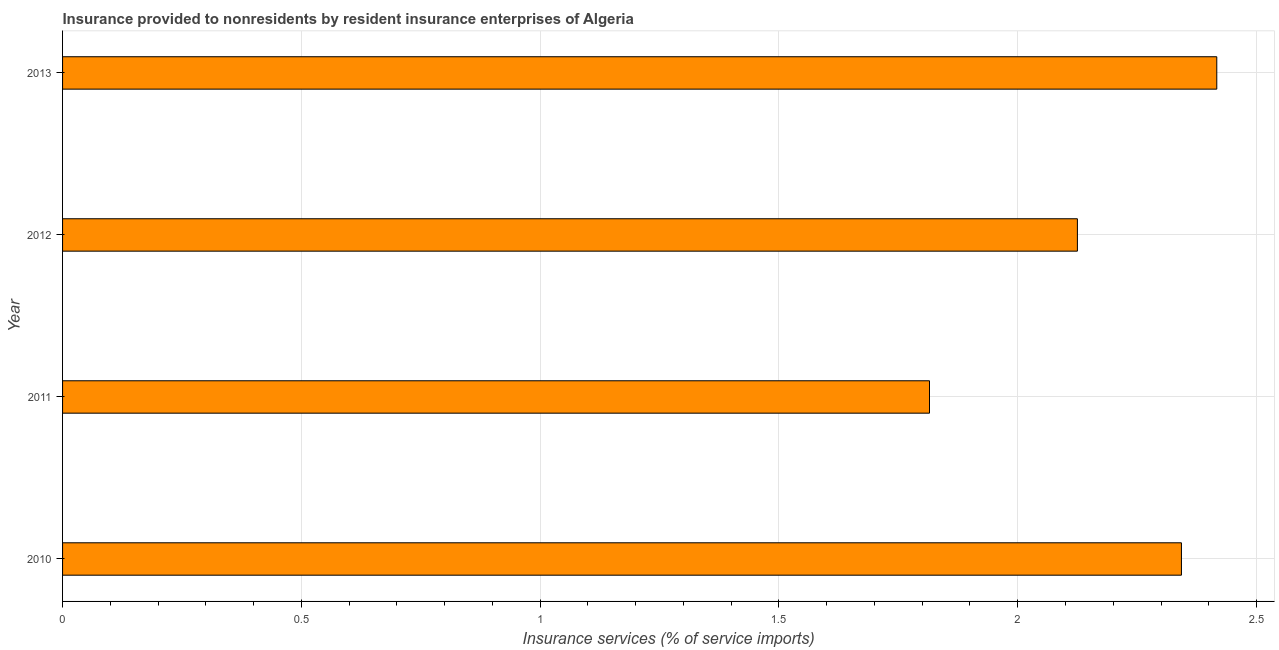Does the graph contain any zero values?
Your answer should be very brief. No. Does the graph contain grids?
Your answer should be compact. Yes. What is the title of the graph?
Your answer should be very brief. Insurance provided to nonresidents by resident insurance enterprises of Algeria. What is the label or title of the X-axis?
Your answer should be very brief. Insurance services (% of service imports). What is the label or title of the Y-axis?
Keep it short and to the point. Year. What is the insurance and financial services in 2011?
Provide a succinct answer. 1.82. Across all years, what is the maximum insurance and financial services?
Provide a short and direct response. 2.42. Across all years, what is the minimum insurance and financial services?
Keep it short and to the point. 1.82. In which year was the insurance and financial services minimum?
Offer a terse response. 2011. What is the sum of the insurance and financial services?
Your answer should be very brief. 8.7. What is the difference between the insurance and financial services in 2010 and 2011?
Make the answer very short. 0.53. What is the average insurance and financial services per year?
Offer a very short reply. 2.17. What is the median insurance and financial services?
Ensure brevity in your answer.  2.23. Do a majority of the years between 2013 and 2012 (inclusive) have insurance and financial services greater than 2 %?
Ensure brevity in your answer.  No. What is the ratio of the insurance and financial services in 2010 to that in 2012?
Ensure brevity in your answer.  1.1. Is the insurance and financial services in 2010 less than that in 2012?
Offer a terse response. No. What is the difference between the highest and the second highest insurance and financial services?
Ensure brevity in your answer.  0.07. In how many years, is the insurance and financial services greater than the average insurance and financial services taken over all years?
Offer a very short reply. 2. Are all the bars in the graph horizontal?
Your answer should be compact. Yes. How many years are there in the graph?
Provide a short and direct response. 4. What is the difference between two consecutive major ticks on the X-axis?
Your answer should be compact. 0.5. Are the values on the major ticks of X-axis written in scientific E-notation?
Your response must be concise. No. What is the Insurance services (% of service imports) of 2010?
Make the answer very short. 2.34. What is the Insurance services (% of service imports) of 2011?
Give a very brief answer. 1.82. What is the Insurance services (% of service imports) of 2012?
Provide a succinct answer. 2.12. What is the Insurance services (% of service imports) in 2013?
Provide a short and direct response. 2.42. What is the difference between the Insurance services (% of service imports) in 2010 and 2011?
Offer a very short reply. 0.53. What is the difference between the Insurance services (% of service imports) in 2010 and 2012?
Give a very brief answer. 0.22. What is the difference between the Insurance services (% of service imports) in 2010 and 2013?
Make the answer very short. -0.07. What is the difference between the Insurance services (% of service imports) in 2011 and 2012?
Ensure brevity in your answer.  -0.31. What is the difference between the Insurance services (% of service imports) in 2011 and 2013?
Your answer should be compact. -0.6. What is the difference between the Insurance services (% of service imports) in 2012 and 2013?
Your answer should be compact. -0.29. What is the ratio of the Insurance services (% of service imports) in 2010 to that in 2011?
Provide a succinct answer. 1.29. What is the ratio of the Insurance services (% of service imports) in 2010 to that in 2012?
Give a very brief answer. 1.1. What is the ratio of the Insurance services (% of service imports) in 2010 to that in 2013?
Your answer should be compact. 0.97. What is the ratio of the Insurance services (% of service imports) in 2011 to that in 2012?
Provide a succinct answer. 0.85. What is the ratio of the Insurance services (% of service imports) in 2011 to that in 2013?
Give a very brief answer. 0.75. What is the ratio of the Insurance services (% of service imports) in 2012 to that in 2013?
Offer a terse response. 0.88. 